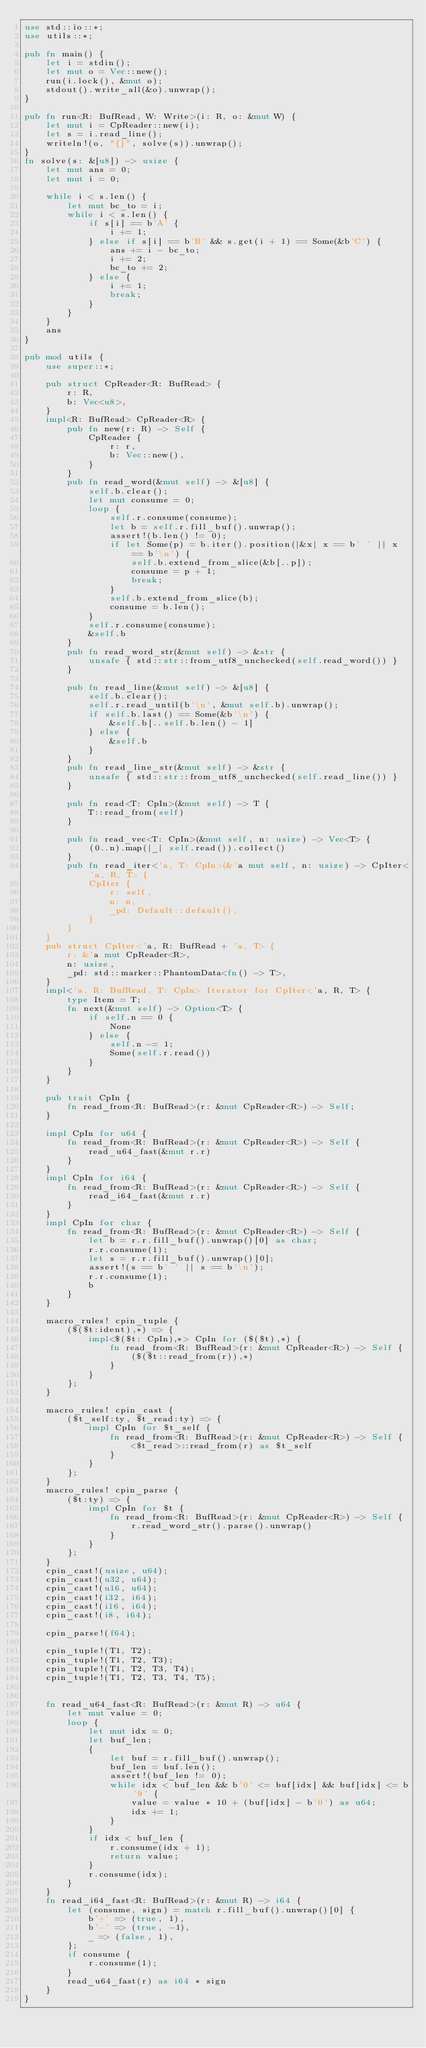<code> <loc_0><loc_0><loc_500><loc_500><_Rust_>use std::io::*;
use utils::*;

pub fn main() {
    let i = stdin();
    let mut o = Vec::new();
    run(i.lock(), &mut o);
    stdout().write_all(&o).unwrap();
}

pub fn run<R: BufRead, W: Write>(i: R, o: &mut W) {
    let mut i = CpReader::new(i);
    let s = i.read_line();
    writeln!(o, "{}", solve(s)).unwrap();
}
fn solve(s: &[u8]) -> usize {
    let mut ans = 0;
    let mut i = 0;

    while i < s.len() {
        let mut bc_to = i;
        while i < s.len() {
            if s[i] == b'A' {
                i += 1;
            } else if s[i] == b'B' && s.get(i + 1) == Some(&b'C') {
                ans += i - bc_to;
                i += 2;
                bc_to += 2;
            } else {
                i += 1;
                break;
            }
        }
    }
    ans
}

pub mod utils {
    use super::*;

    pub struct CpReader<R: BufRead> {
        r: R,
        b: Vec<u8>,
    }
    impl<R: BufRead> CpReader<R> {
        pub fn new(r: R) -> Self {
            CpReader {
                r: r,
                b: Vec::new(),
            }
        }
        pub fn read_word(&mut self) -> &[u8] {
            self.b.clear();
            let mut consume = 0;
            loop {
                self.r.consume(consume);
                let b = self.r.fill_buf().unwrap();
                assert!(b.len() != 0);
                if let Some(p) = b.iter().position(|&x| x == b' ' || x == b'\n') {
                    self.b.extend_from_slice(&b[..p]);
                    consume = p + 1;
                    break;
                }
                self.b.extend_from_slice(b);
                consume = b.len();
            }
            self.r.consume(consume);
            &self.b
        }
        pub fn read_word_str(&mut self) -> &str {
            unsafe { std::str::from_utf8_unchecked(self.read_word()) }
        }

        pub fn read_line(&mut self) -> &[u8] {
            self.b.clear();
            self.r.read_until(b'\n', &mut self.b).unwrap();
            if self.b.last() == Some(&b'\n') {
                &self.b[..self.b.len() - 1]
            } else {
                &self.b
            }
        }
        pub fn read_line_str(&mut self) -> &str {
            unsafe { std::str::from_utf8_unchecked(self.read_line()) }
        }

        pub fn read<T: CpIn>(&mut self) -> T {
            T::read_from(self)
        }

        pub fn read_vec<T: CpIn>(&mut self, n: usize) -> Vec<T> {
            (0..n).map(|_| self.read()).collect()
        }
        pub fn read_iter<'a, T: CpIn>(&'a mut self, n: usize) -> CpIter<'a, R, T> {
            CpIter {
                r: self,
                n: n,
                _pd: Default::default(),
            }
        }
    }
    pub struct CpIter<'a, R: BufRead + 'a, T> {
        r: &'a mut CpReader<R>,
        n: usize,
        _pd: std::marker::PhantomData<fn() -> T>,
    }
    impl<'a, R: BufRead, T: CpIn> Iterator for CpIter<'a, R, T> {
        type Item = T;
        fn next(&mut self) -> Option<T> {
            if self.n == 0 {
                None
            } else {
                self.n -= 1;
                Some(self.r.read())
            }
        }
    }

    pub trait CpIn {
        fn read_from<R: BufRead>(r: &mut CpReader<R>) -> Self;
    }

    impl CpIn for u64 {
        fn read_from<R: BufRead>(r: &mut CpReader<R>) -> Self {
            read_u64_fast(&mut r.r)
        }
    }
    impl CpIn for i64 {
        fn read_from<R: BufRead>(r: &mut CpReader<R>) -> Self {
            read_i64_fast(&mut r.r)
        }
    }
    impl CpIn for char {
        fn read_from<R: BufRead>(r: &mut CpReader<R>) -> Self {
            let b = r.r.fill_buf().unwrap()[0] as char;
            r.r.consume(1);
            let s = r.r.fill_buf().unwrap()[0];
            assert!(s == b' ' || s == b'\n');
            r.r.consume(1);
            b
        }
    }

    macro_rules! cpin_tuple {
        ($($t:ident),*) => {
            impl<$($t: CpIn),*> CpIn for ($($t),*) {
                fn read_from<R: BufRead>(r: &mut CpReader<R>) -> Self {
                    ($($t::read_from(r)),*)
                }
            }
        };
    }

    macro_rules! cpin_cast {
        ($t_self:ty, $t_read:ty) => {
            impl CpIn for $t_self {
                fn read_from<R: BufRead>(r: &mut CpReader<R>) -> Self {
                    <$t_read>::read_from(r) as $t_self
                }
            }
        };
    }
    macro_rules! cpin_parse {
        ($t:ty) => {
            impl CpIn for $t {
                fn read_from<R: BufRead>(r: &mut CpReader<R>) -> Self {
                    r.read_word_str().parse().unwrap()
                }
            }
        };
    }
    cpin_cast!(usize, u64);
    cpin_cast!(u32, u64);
    cpin_cast!(u16, u64);
    cpin_cast!(i32, i64);
    cpin_cast!(i16, i64);
    cpin_cast!(i8, i64);

    cpin_parse!(f64);

    cpin_tuple!(T1, T2);
    cpin_tuple!(T1, T2, T3);
    cpin_tuple!(T1, T2, T3, T4);
    cpin_tuple!(T1, T2, T3, T4, T5);


    fn read_u64_fast<R: BufRead>(r: &mut R) -> u64 {
        let mut value = 0;
        loop {
            let mut idx = 0;
            let buf_len;
            {
                let buf = r.fill_buf().unwrap();
                buf_len = buf.len();
                assert!(buf_len != 0);
                while idx < buf_len && b'0' <= buf[idx] && buf[idx] <= b'9' {
                    value = value * 10 + (buf[idx] - b'0') as u64;
                    idx += 1;
                }
            }
            if idx < buf_len {
                r.consume(idx + 1);
                return value;
            }
            r.consume(idx);
        }
    }
    fn read_i64_fast<R: BufRead>(r: &mut R) -> i64 {
        let (consume, sign) = match r.fill_buf().unwrap()[0] {
            b'+' => (true, 1),
            b'-' => (true, -1),
            _ => (false, 1),
        };
        if consume {
            r.consume(1);
        }
        read_u64_fast(r) as i64 * sign
    }
}

</code> 